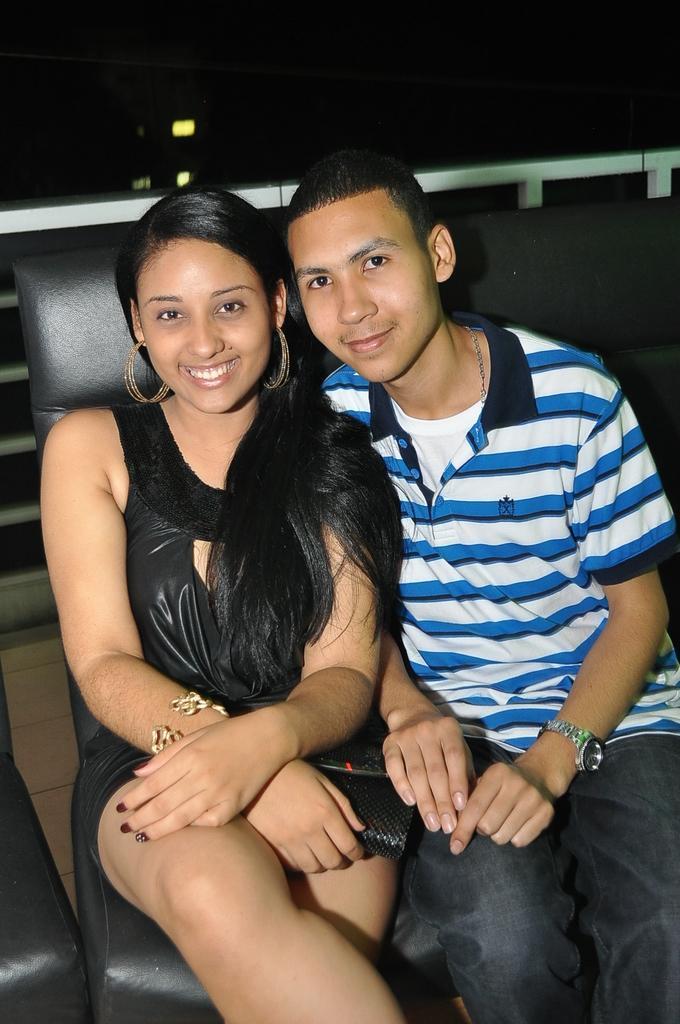Can you describe this image briefly? In this image, we can see a girl and a boy sitting on the sofa and there are smiling. 